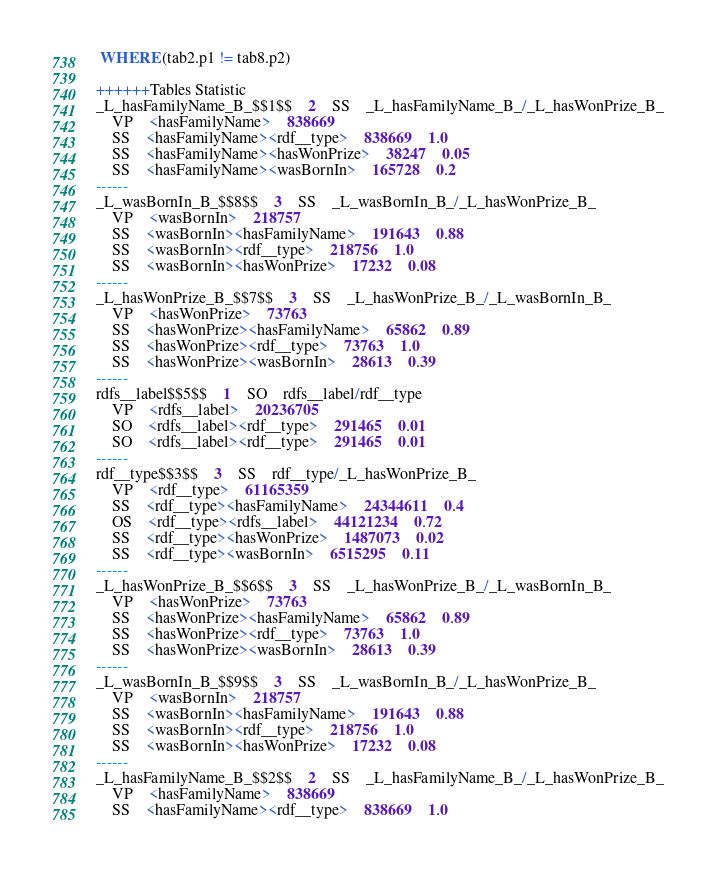<code> <loc_0><loc_0><loc_500><loc_500><_SQL_> WHERE (tab2.p1 != tab8.p2)

++++++Tables Statistic
_L_hasFamilyName_B_$$1$$	2	SS	_L_hasFamilyName_B_/_L_hasWonPrize_B_
	VP	<hasFamilyName>	838669
	SS	<hasFamilyName><rdf__type>	838669	1.0
	SS	<hasFamilyName><hasWonPrize>	38247	0.05
	SS	<hasFamilyName><wasBornIn>	165728	0.2
------
_L_wasBornIn_B_$$8$$	3	SS	_L_wasBornIn_B_/_L_hasWonPrize_B_
	VP	<wasBornIn>	218757
	SS	<wasBornIn><hasFamilyName>	191643	0.88
	SS	<wasBornIn><rdf__type>	218756	1.0
	SS	<wasBornIn><hasWonPrize>	17232	0.08
------
_L_hasWonPrize_B_$$7$$	3	SS	_L_hasWonPrize_B_/_L_wasBornIn_B_
	VP	<hasWonPrize>	73763
	SS	<hasWonPrize><hasFamilyName>	65862	0.89
	SS	<hasWonPrize><rdf__type>	73763	1.0
	SS	<hasWonPrize><wasBornIn>	28613	0.39
------
rdfs__label$$5$$	1	SO	rdfs__label/rdf__type
	VP	<rdfs__label>	20236705
	SO	<rdfs__label><rdf__type>	291465	0.01
	SO	<rdfs__label><rdf__type>	291465	0.01
------
rdf__type$$3$$	3	SS	rdf__type/_L_hasWonPrize_B_
	VP	<rdf__type>	61165359
	SS	<rdf__type><hasFamilyName>	24344611	0.4
	OS	<rdf__type><rdfs__label>	44121234	0.72
	SS	<rdf__type><hasWonPrize>	1487073	0.02
	SS	<rdf__type><wasBornIn>	6515295	0.11
------
_L_hasWonPrize_B_$$6$$	3	SS	_L_hasWonPrize_B_/_L_wasBornIn_B_
	VP	<hasWonPrize>	73763
	SS	<hasWonPrize><hasFamilyName>	65862	0.89
	SS	<hasWonPrize><rdf__type>	73763	1.0
	SS	<hasWonPrize><wasBornIn>	28613	0.39
------
_L_wasBornIn_B_$$9$$	3	SS	_L_wasBornIn_B_/_L_hasWonPrize_B_
	VP	<wasBornIn>	218757
	SS	<wasBornIn><hasFamilyName>	191643	0.88
	SS	<wasBornIn><rdf__type>	218756	1.0
	SS	<wasBornIn><hasWonPrize>	17232	0.08
------
_L_hasFamilyName_B_$$2$$	2	SS	_L_hasFamilyName_B_/_L_hasWonPrize_B_
	VP	<hasFamilyName>	838669
	SS	<hasFamilyName><rdf__type>	838669	1.0</code> 